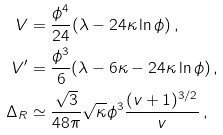<formula> <loc_0><loc_0><loc_500><loc_500>V & = \frac { \phi ^ { 4 } } { 2 4 } ( \lambda - 2 4 \kappa \ln \phi ) \, , \\ V ^ { \prime } & = \frac { \phi ^ { 3 } } { 6 } ( \lambda - 6 \kappa - 2 4 \kappa \ln \phi ) \, , \\ \Delta _ { R } & \simeq \frac { \sqrt { 3 } } { 4 8 \pi } \sqrt { \kappa } \phi ^ { 3 } \frac { ( v + 1 ) ^ { 3 / 2 } } { v } \, ,</formula> 